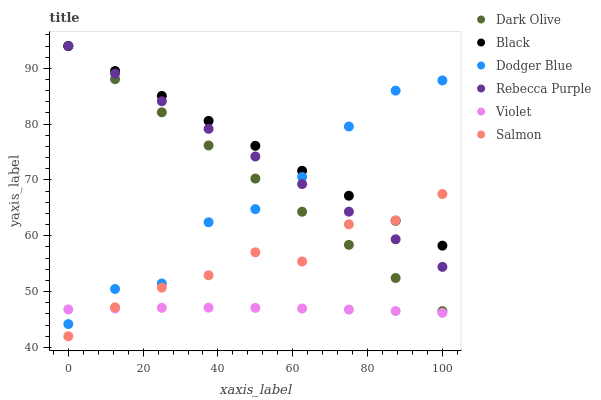Does Violet have the minimum area under the curve?
Answer yes or no. Yes. Does Black have the maximum area under the curve?
Answer yes or no. Yes. Does Salmon have the minimum area under the curve?
Answer yes or no. No. Does Salmon have the maximum area under the curve?
Answer yes or no. No. Is Rebecca Purple the smoothest?
Answer yes or no. Yes. Is Dodger Blue the roughest?
Answer yes or no. Yes. Is Salmon the smoothest?
Answer yes or no. No. Is Salmon the roughest?
Answer yes or no. No. Does Salmon have the lowest value?
Answer yes or no. Yes. Does Dodger Blue have the lowest value?
Answer yes or no. No. Does Black have the highest value?
Answer yes or no. Yes. Does Salmon have the highest value?
Answer yes or no. No. Is Violet less than Rebecca Purple?
Answer yes or no. Yes. Is Black greater than Violet?
Answer yes or no. Yes. Does Dodger Blue intersect Rebecca Purple?
Answer yes or no. Yes. Is Dodger Blue less than Rebecca Purple?
Answer yes or no. No. Is Dodger Blue greater than Rebecca Purple?
Answer yes or no. No. Does Violet intersect Rebecca Purple?
Answer yes or no. No. 